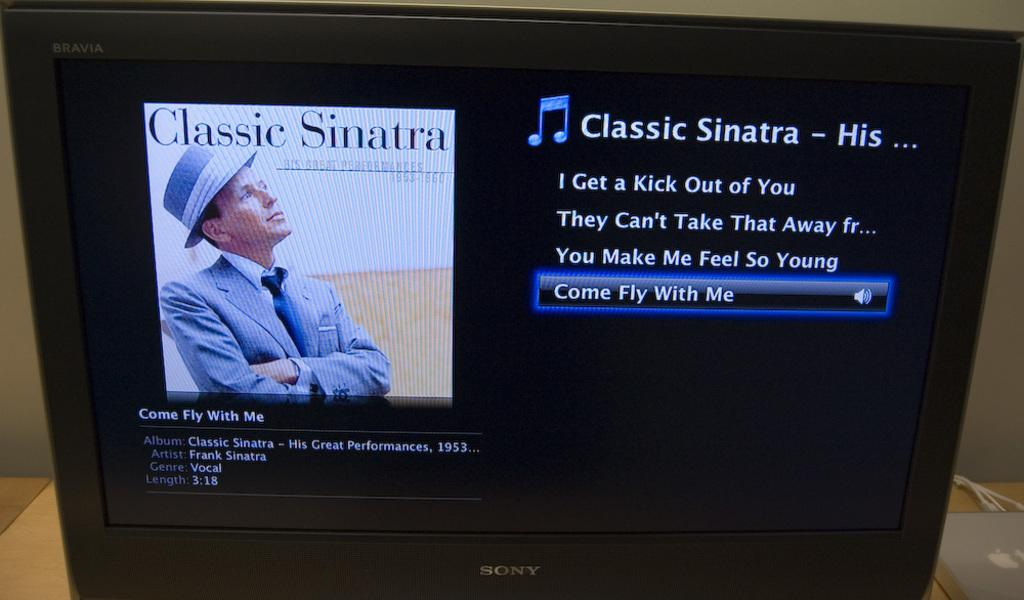<image>
Describe the image concisely. a classic sinatra album that is on the tv 